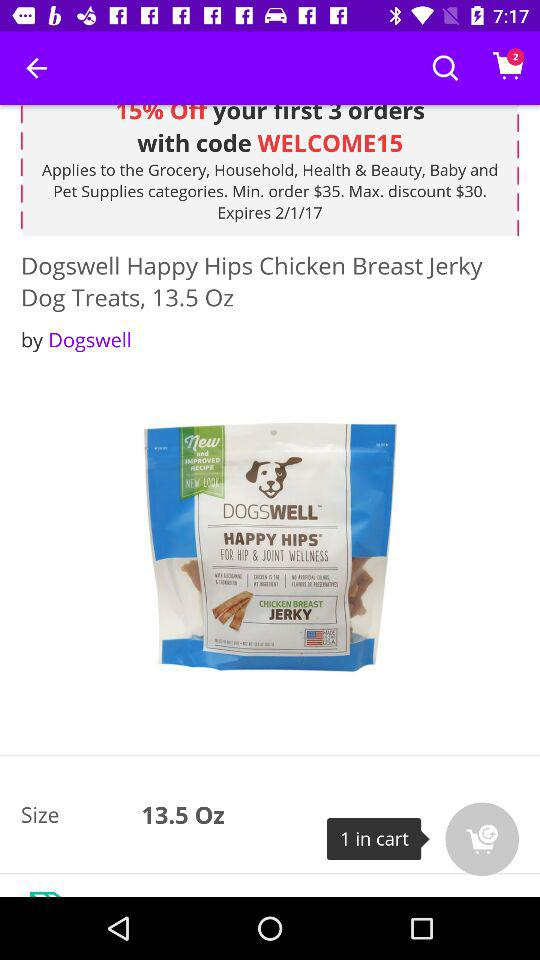How much do the dog treats cost?
When the provided information is insufficient, respond with <no answer>. <no answer> 